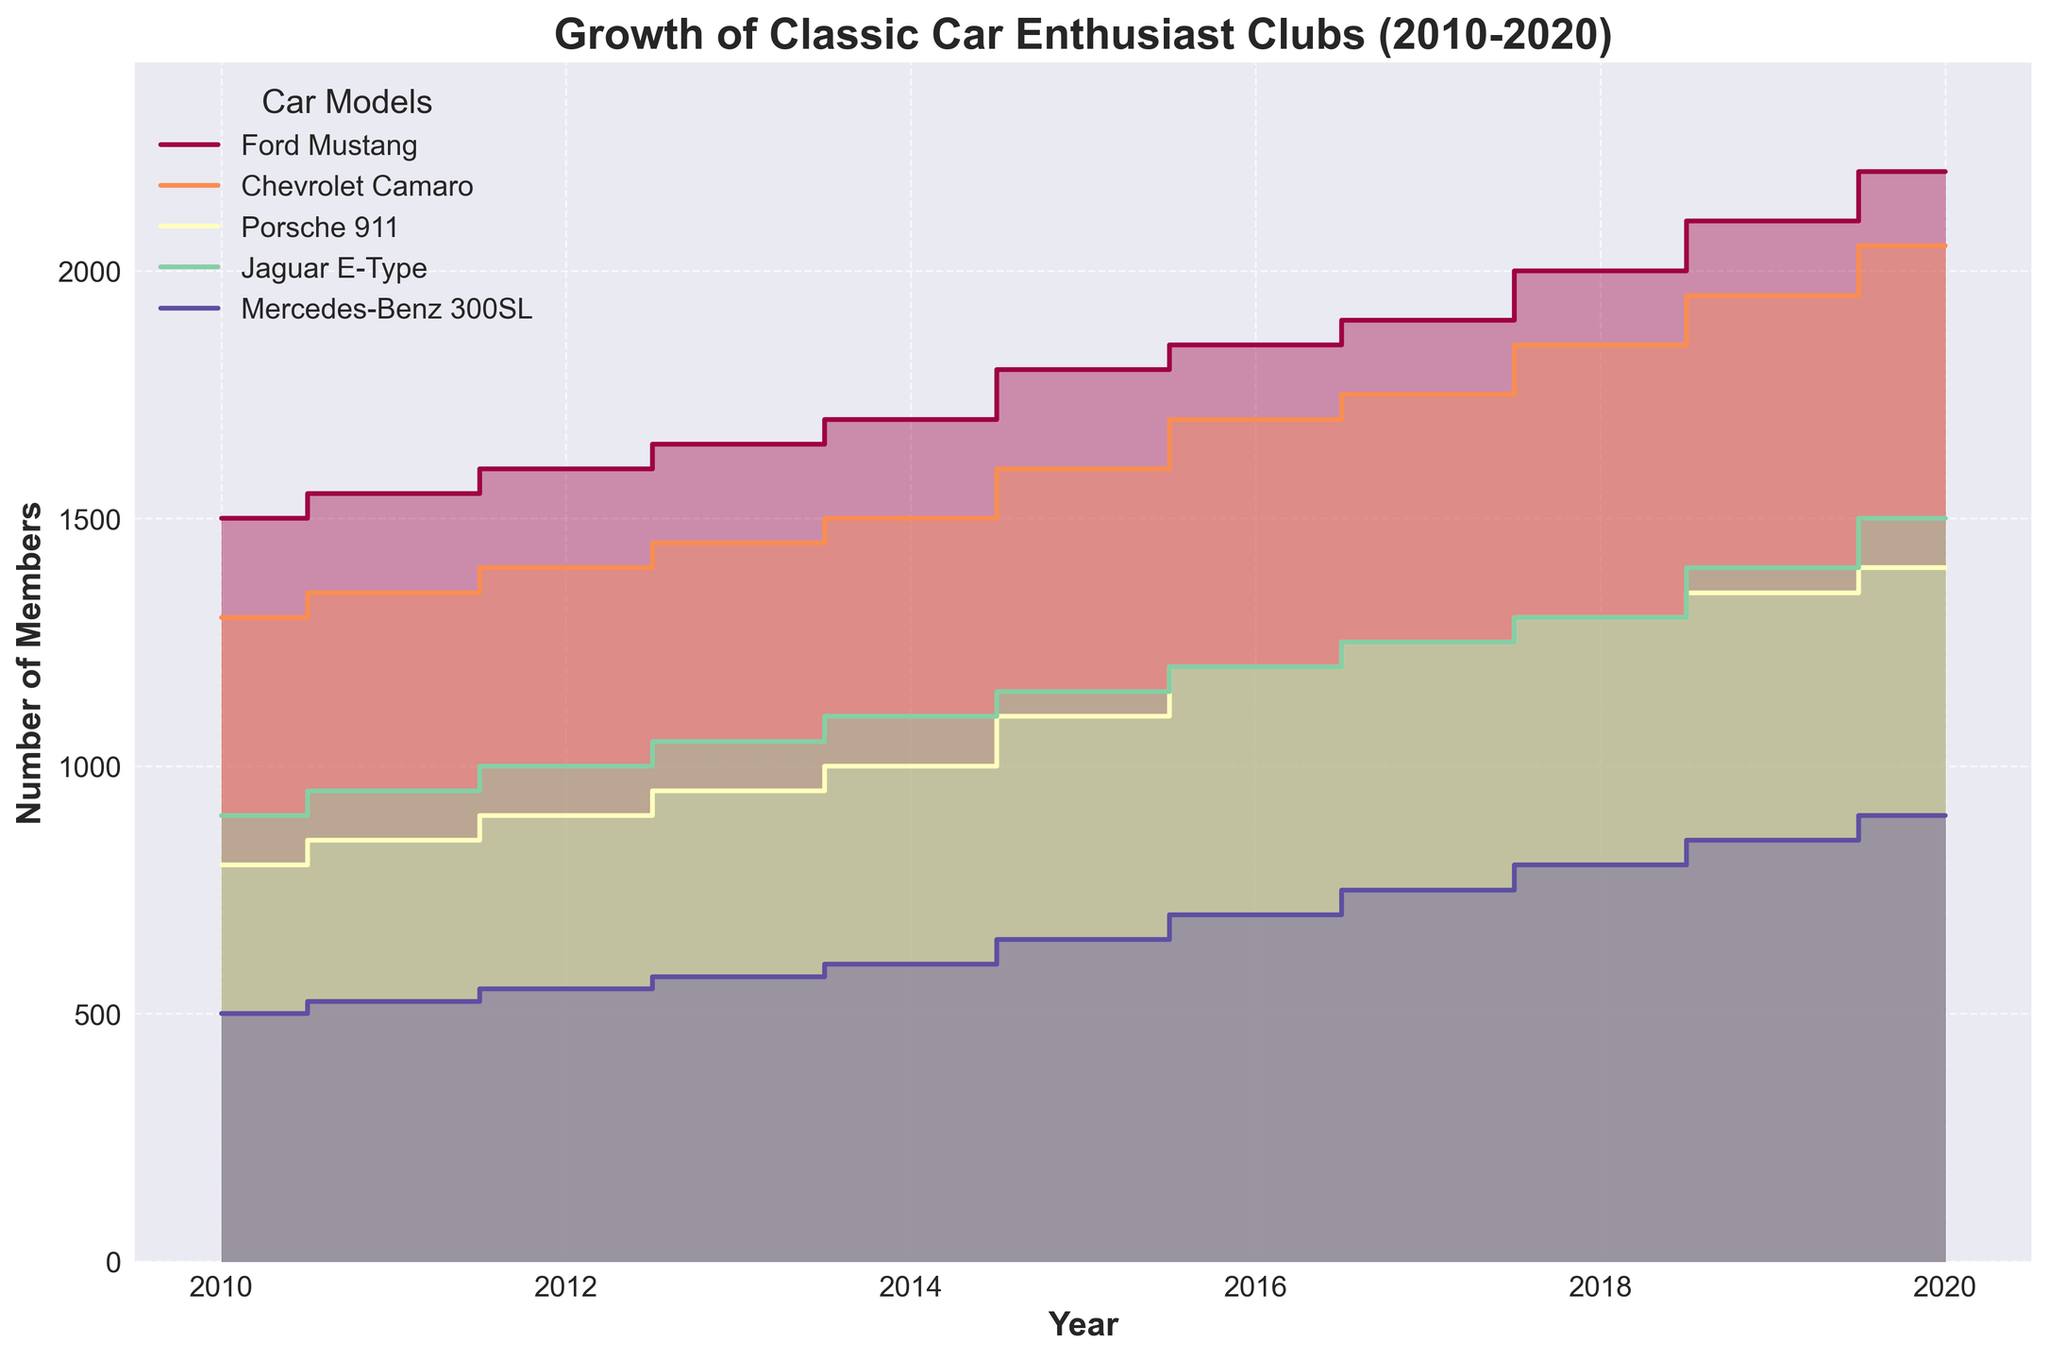What is the overall trend in membership for the Ford Mustang enthusiast club from 2010 to 2020? The plot shows the membership count for the Ford Mustang enthusiast club rising consistently from 1500 in 2010 to 2200 in 2020.
Answer: Membership is increasing Which car model had the highest number of members in 2020? By looking at the plot, the Ford Mustang shows the highest membership count in 2020 at 2200 members.
Answer: Ford Mustang How many members did the Chevrolet Camaro club have in 2015, and how does it compare to 2010? In 2015, the Chevrolet Camaro club had 1600 members. In 2010, it had 1300 members. The difference is 1600 - 1300 = 300, meaning there were 300 more members in 2015.
Answer: 1600 in 2015, 300 more than in 2010 What is the approximate percentage increase in membership for the Porsche 911 enthusiast club from 2010 to 2020? Membership increased from 800 in 2010 to 1400 in 2020. The percentage increase is calculated as ((1400 - 800) / 800) * 100%.
Answer: Approximately 75% Which car model had the smallest growth in membership from 2010 to 2020? By comparing the start and end membership numbers for all car models, the Mercedes-Benz 300SL shows the smallest growth, from 500 in 2010 to 900 in 2020, a growth of 400 members.
Answer: Mercedes-Benz 300SL Among all car models, which had the most consistent increase in membership each year? By observing the step-like nature of each plot, the Ford Mustang shows a very consistent increase with approximately equal steps in membership each year.
Answer: Ford Mustang How did the membership of the Jaguar E-Type enthusiast club change between 2012 and 2016? In 2012, the membership was 1000, and by 2016, it had increased to 1200. The change is 1200 - 1000 = 200, showing a consistent annual increase.
Answer: Increased by 200 members Which car model’s membership grew the fastest between 2016 and 2020? Comparing the steepness of the plots between these years, the Chevrolet Camaro saw a considerable increase from 1700 to 2050, which is a difference of 350 members.
Answer: Chevrolet Camaro 